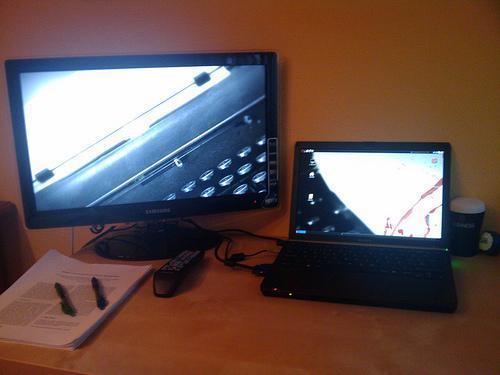How many screens can you see?
Give a very brief answer. 2. How many pens are there?
Give a very brief answer. 2. 